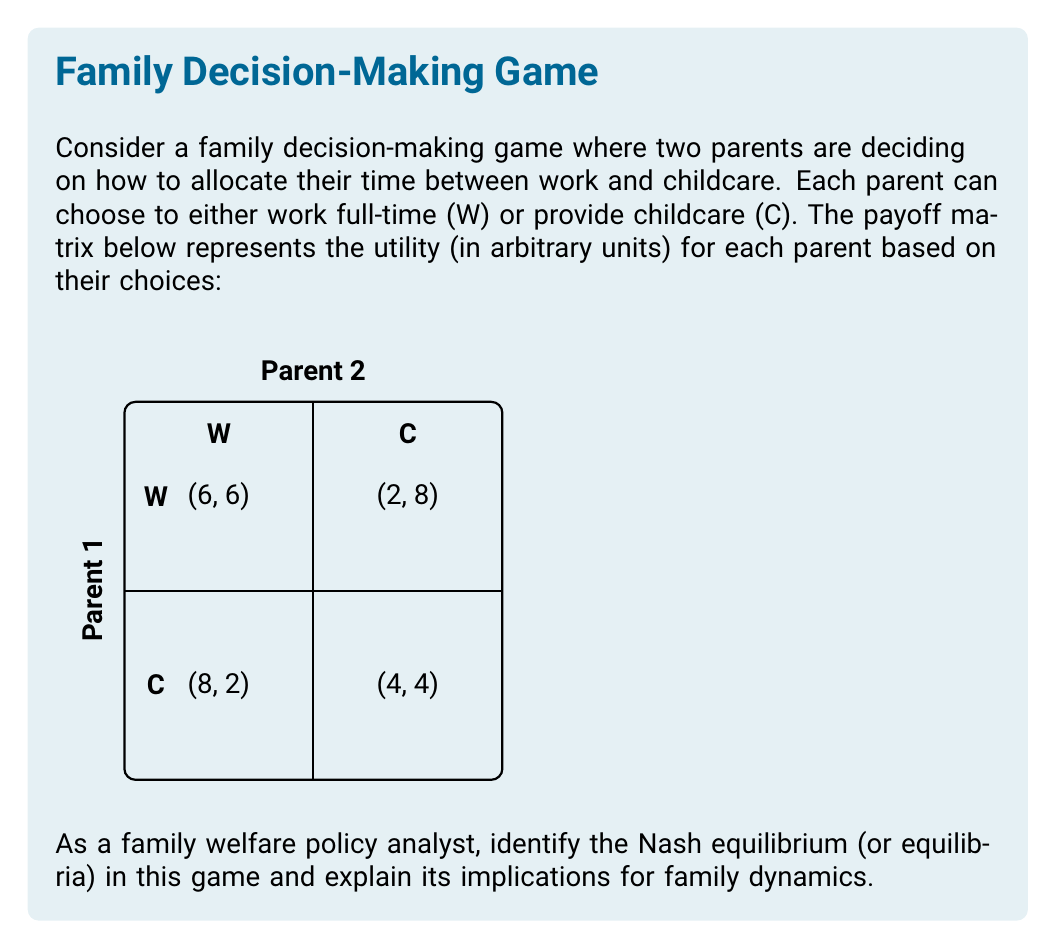Could you help me with this problem? To find the Nash equilibrium, we need to analyze each player's best response to the other player's strategy:

1. For Parent 1:
   - If Parent 2 chooses W, Parent 1's best response is W (6 > 2)
   - If Parent 2 chooses C, Parent 1's best response is W (8 > 4)

2. For Parent 2:
   - If Parent 1 chooses W, Parent 2's best response is W (6 > 2)
   - If Parent 1 chooses C, Parent 2's best response is W (8 > 4)

We can see that regardless of what the other parent chooses, each parent's best strategy is to work (W). This means that (W, W) is the only Nash equilibrium in this game.

To verify, let's check if any player has an incentive to deviate:
- If Parent 1 deviates to C while Parent 2 stays at W, their payoff decreases from 6 to 2.
- If Parent 2 deviates to C while Parent 1 stays at W, their payoff decreases from 6 to 2.

Neither player can improve their payoff by unilaterally changing their strategy, confirming that (W, W) is indeed a Nash equilibrium.

Implications for family dynamics:
1. This equilibrium suggests that both parents are incentivized to work full-time, potentially leaving a gap in childcare.
2. The outcome (6, 6) is not Pareto optimal, as (8, 8) would be better for both parents, but it's not achievable as a stable outcome.
3. This situation might lead to the need for external childcare solutions or policy interventions to balance work and family responsibilities.

As a family welfare policy analyst, you might consider recommending policies that:
- Provide incentives for parents to share childcare responsibilities
- Offer subsidies for childcare to make the (C, C) outcome more attractive
- Implement flexible work arrangements to allow for a better work-life balance

These considerations could help in designing policies that promote both economic productivity and family well-being.
Answer: Nash equilibrium: (W, W) 